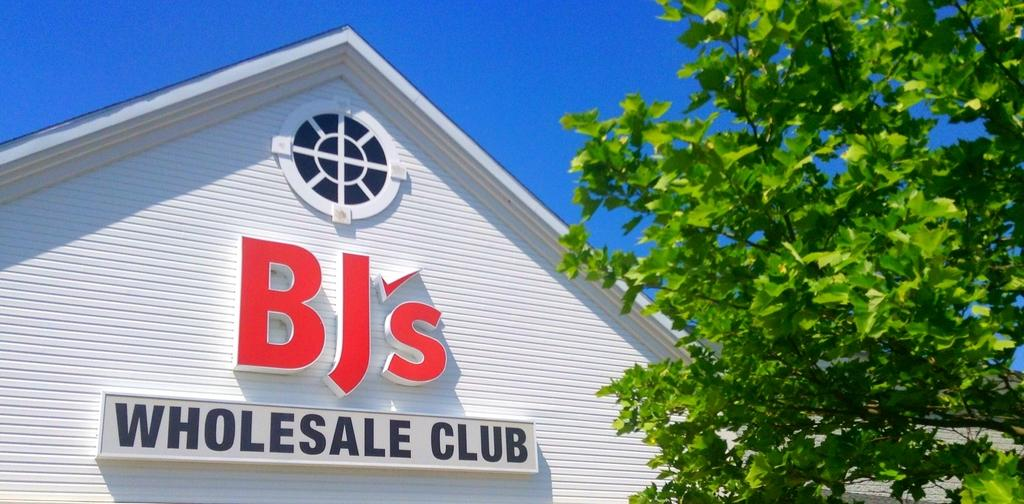What can be seen written on the wall in the image? There is a name of an organization on a wall in the image. What is located beside the wall in the image? There is a tree beside the wall in the image. What type of patch is visible on the tree in the image? There is no patch visible on the tree in the image. How much payment is being made to the organization in the image? There is no payment being made in the image; it only shows the name of the organization on a wall. 